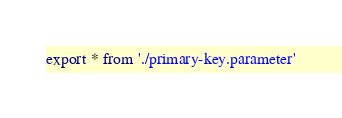Convert code to text. <code><loc_0><loc_0><loc_500><loc_500><_TypeScript_>export * from './primary-key.parameter'
</code> 